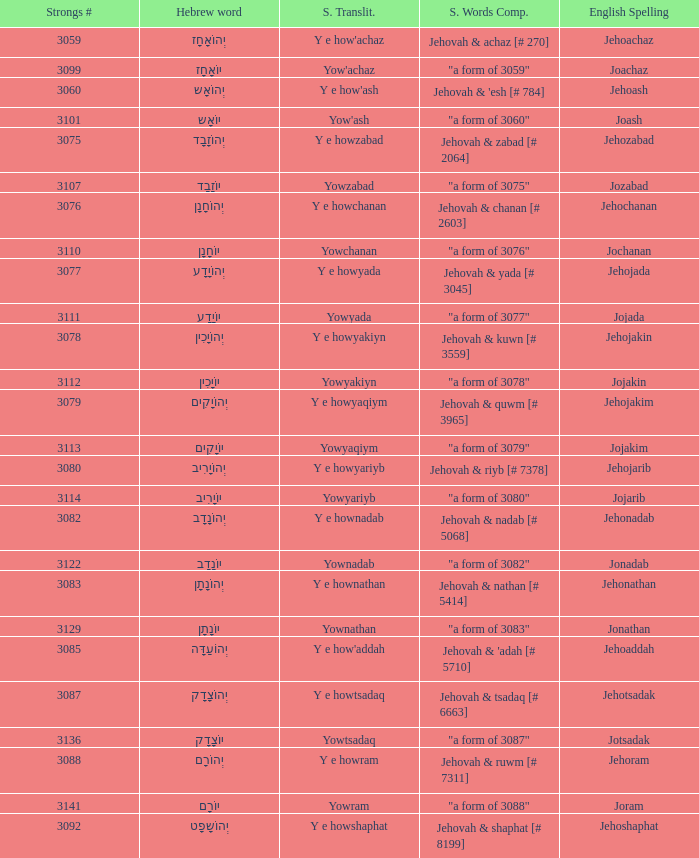How many strongs transliteration of the english spelling of the work jehojakin? 1.0. 